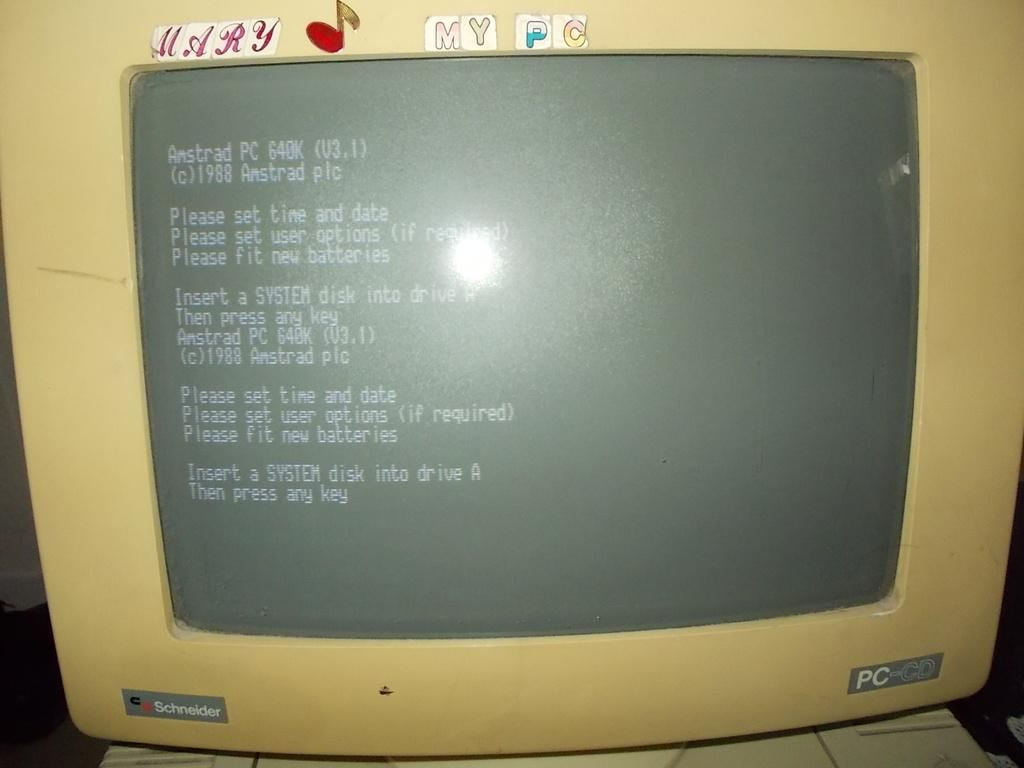<image>
Describe the image concisely. an old PC-CD computer monitor made by Schneider 